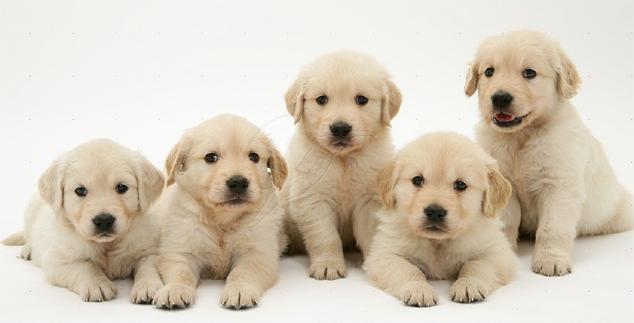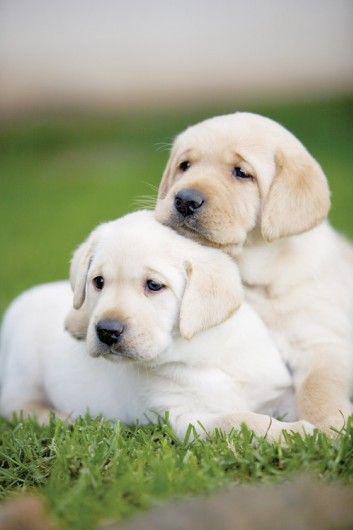The first image is the image on the left, the second image is the image on the right. Analyze the images presented: Is the assertion "there are exactly three animals in the image on the left" valid? Answer yes or no. No. The first image is the image on the left, the second image is the image on the right. Considering the images on both sides, is "The left image shows a total of 3 dogs" valid? Answer yes or no. No. 